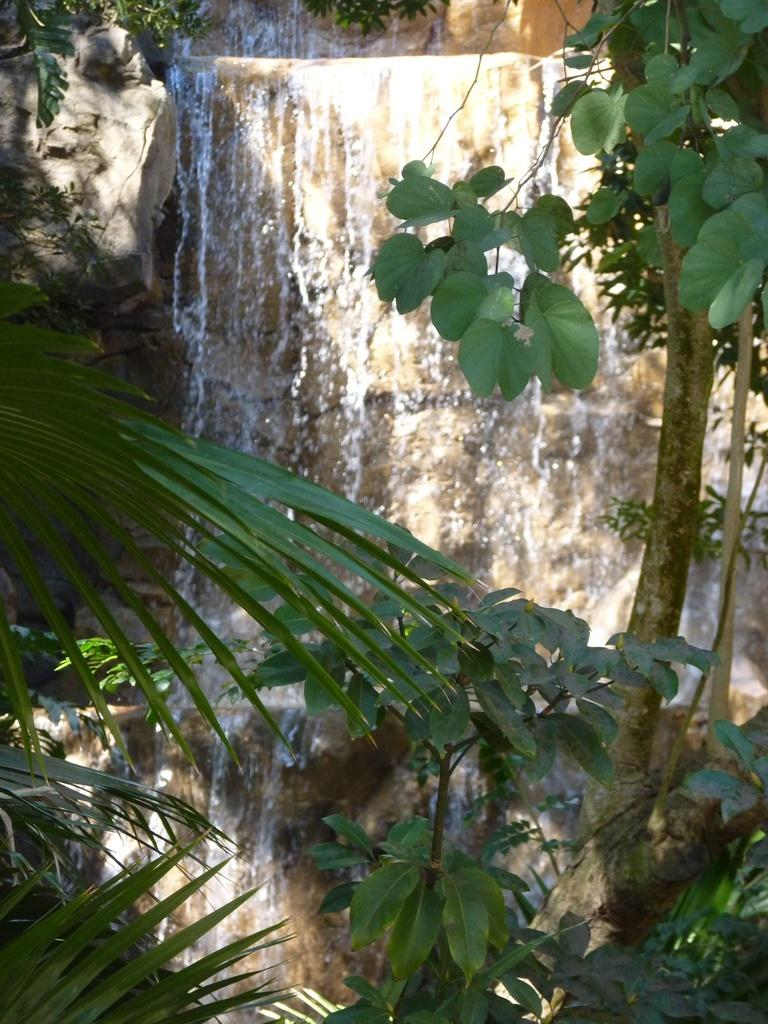What is located in the center of the image? There is a wall in the center of the image. What can be seen on the right side of the image? There are plants on the right side of the image. What can be seen on the left side of the image? There are plants on the left side of the image. What type of skin can be seen on the plants in the image? There is no mention of skin in the image, as it features a wall and plants. 